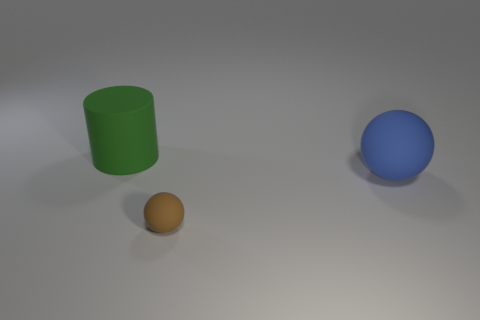Add 3 blue balls. How many objects exist? 6 Subtract all spheres. How many objects are left? 1 Subtract all red rubber blocks. Subtract all blue matte spheres. How many objects are left? 2 Add 3 tiny objects. How many tiny objects are left? 4 Add 2 blue spheres. How many blue spheres exist? 3 Subtract 0 purple blocks. How many objects are left? 3 